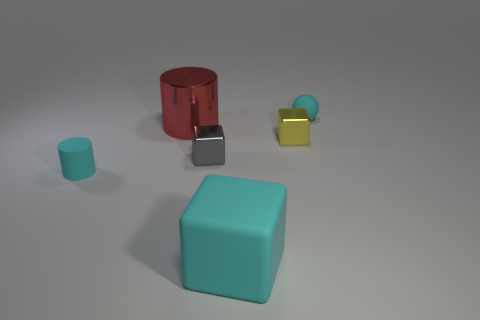There is a cube that is the same color as the sphere; what size is it?
Your answer should be very brief. Large. What number of other things are the same size as the red metal cylinder?
Offer a terse response. 1. The big object that is in front of the small matte thing that is on the left side of the small cyan thing that is behind the tiny yellow object is what shape?
Offer a terse response. Cube. Does the shiny cylinder have the same size as the cyan matte block in front of the red shiny cylinder?
Your answer should be compact. Yes. There is a small object that is both left of the small matte ball and to the right of the large cyan cube; what is its color?
Keep it short and to the point. Yellow. What number of other objects are the same shape as the red shiny thing?
Your answer should be compact. 1. There is a small object in front of the small gray cube; is its color the same as the tiny rubber thing that is to the right of the large matte thing?
Ensure brevity in your answer.  Yes. Does the cyan rubber thing that is behind the large shiny cylinder have the same size as the cylinder in front of the red metal cylinder?
Provide a succinct answer. Yes. There is a small object behind the small cube to the right of the gray shiny thing behind the cyan rubber cube; what is it made of?
Provide a short and direct response. Rubber. Is the tiny gray metallic thing the same shape as the large cyan object?
Your answer should be very brief. Yes. 